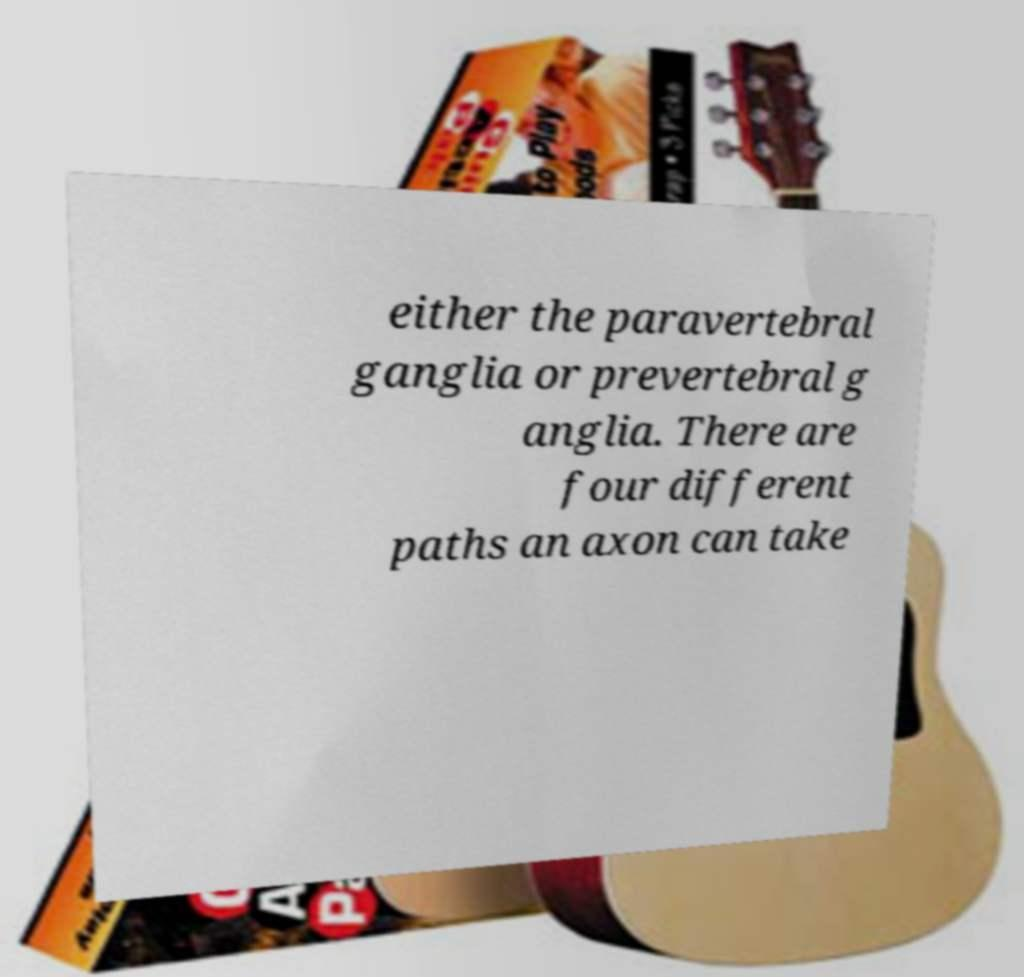Could you assist in decoding the text presented in this image and type it out clearly? either the paravertebral ganglia or prevertebral g anglia. There are four different paths an axon can take 